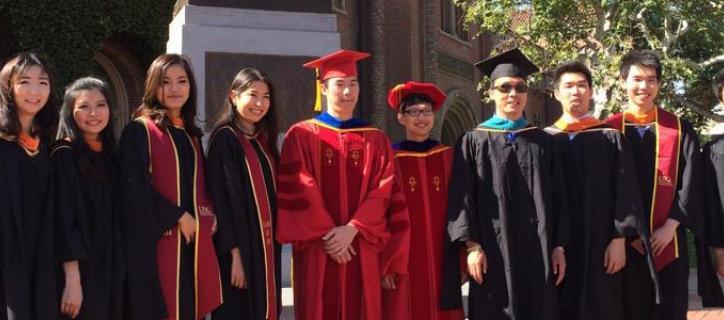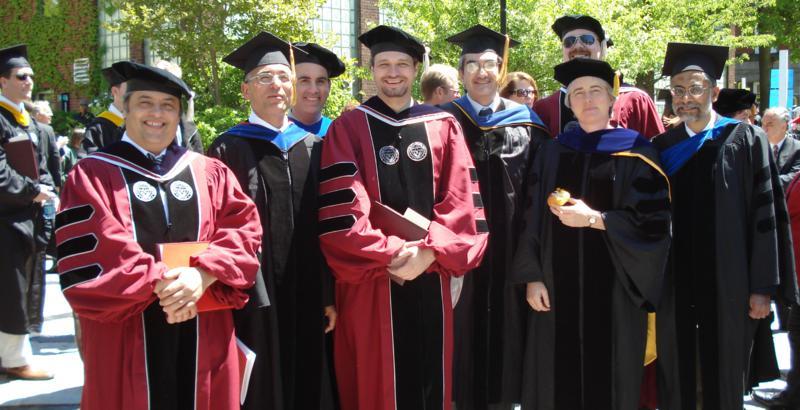The first image is the image on the left, the second image is the image on the right. Analyze the images presented: Is the assertion "One image shows a group of graduates posed outdoors wearing different colored robes with three black stripes per sleeve." valid? Answer yes or no. Yes. The first image is the image on the left, the second image is the image on the right. Assess this claim about the two images: "The graduates in each picture are posing outside.". Correct or not? Answer yes or no. Yes. 